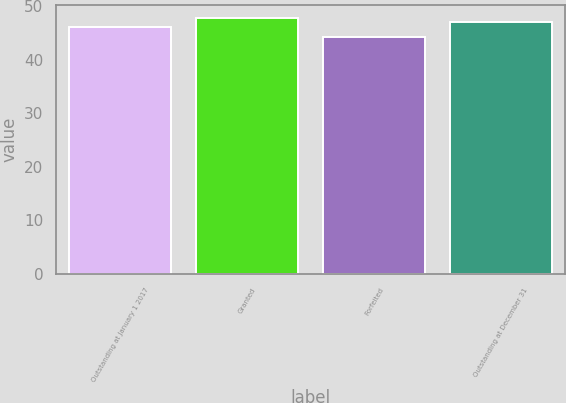Convert chart. <chart><loc_0><loc_0><loc_500><loc_500><bar_chart><fcel>Outstanding at January 1 2017<fcel>Granted<fcel>Forfeited<fcel>Outstanding at December 31<nl><fcel>46.15<fcel>47.79<fcel>44.19<fcel>47.04<nl></chart> 